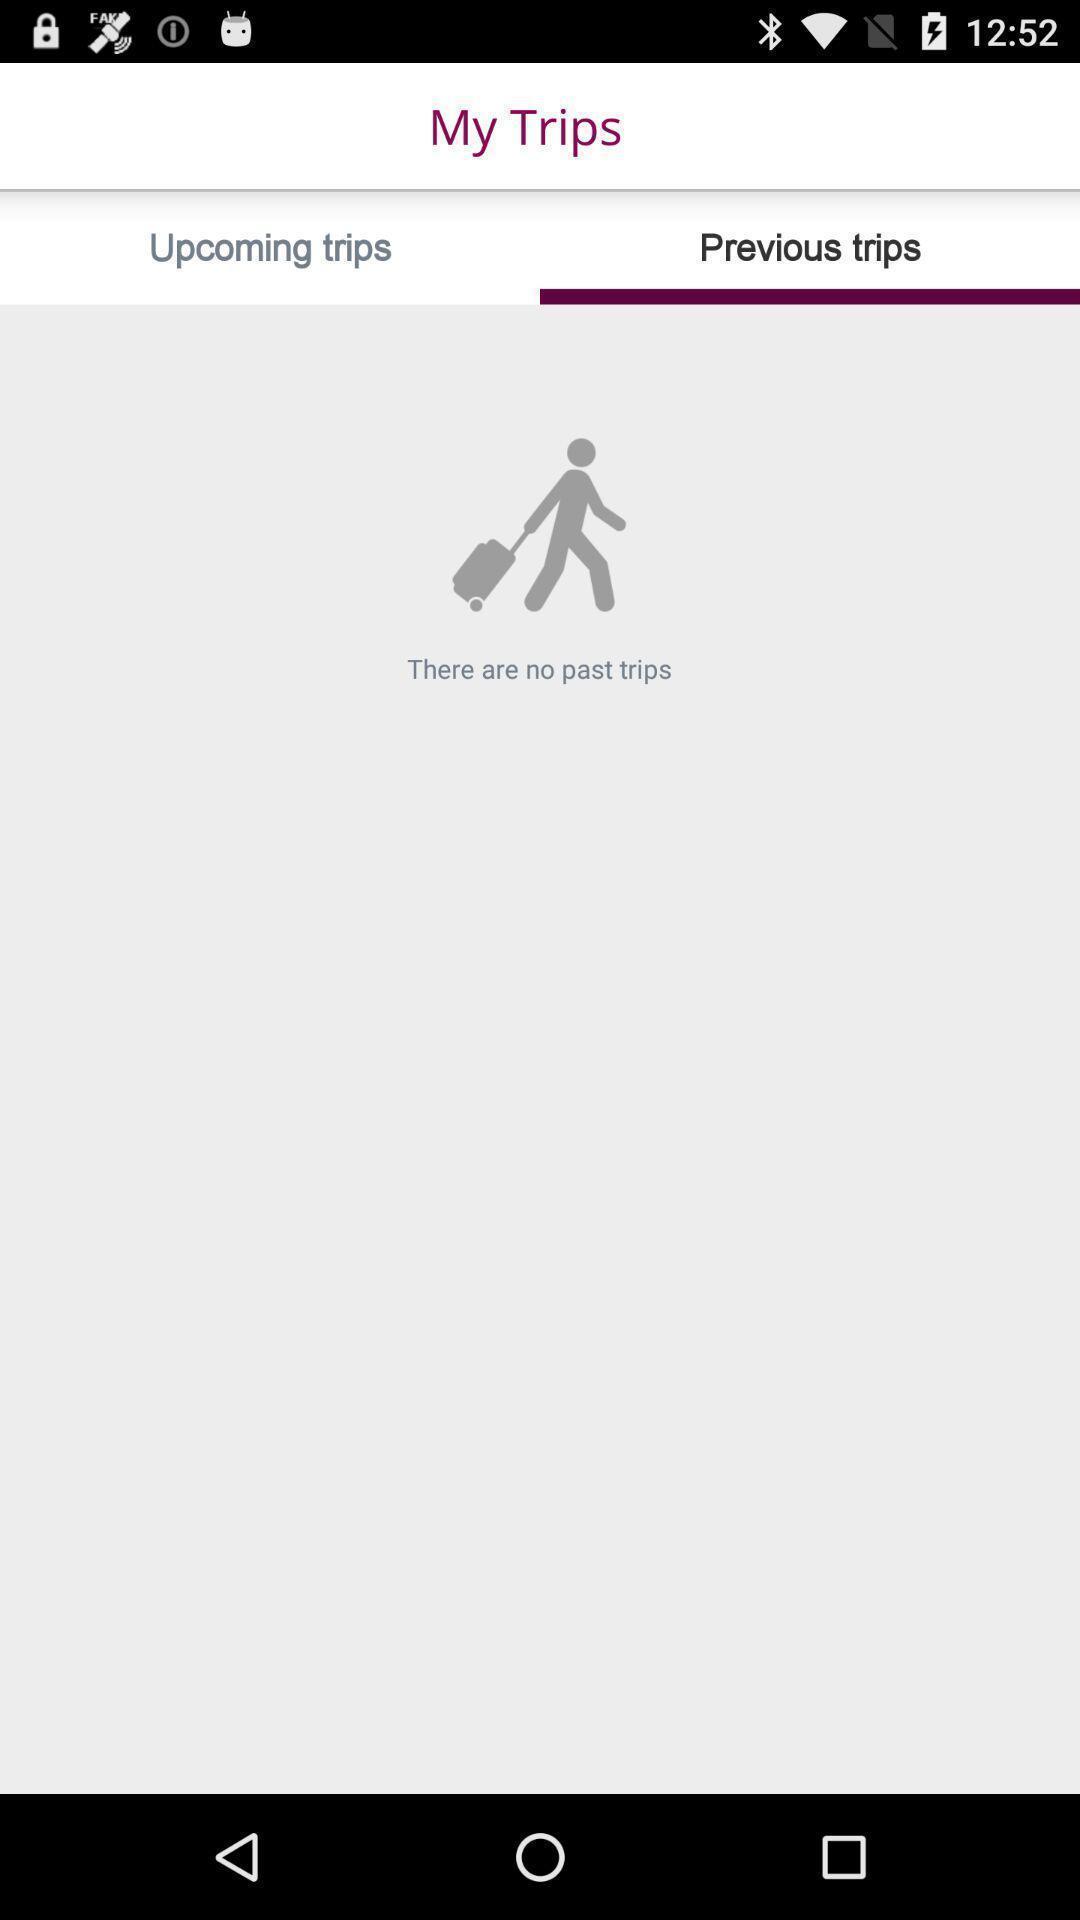Summarize the main components in this picture. Screen displaying the previous trips page. 